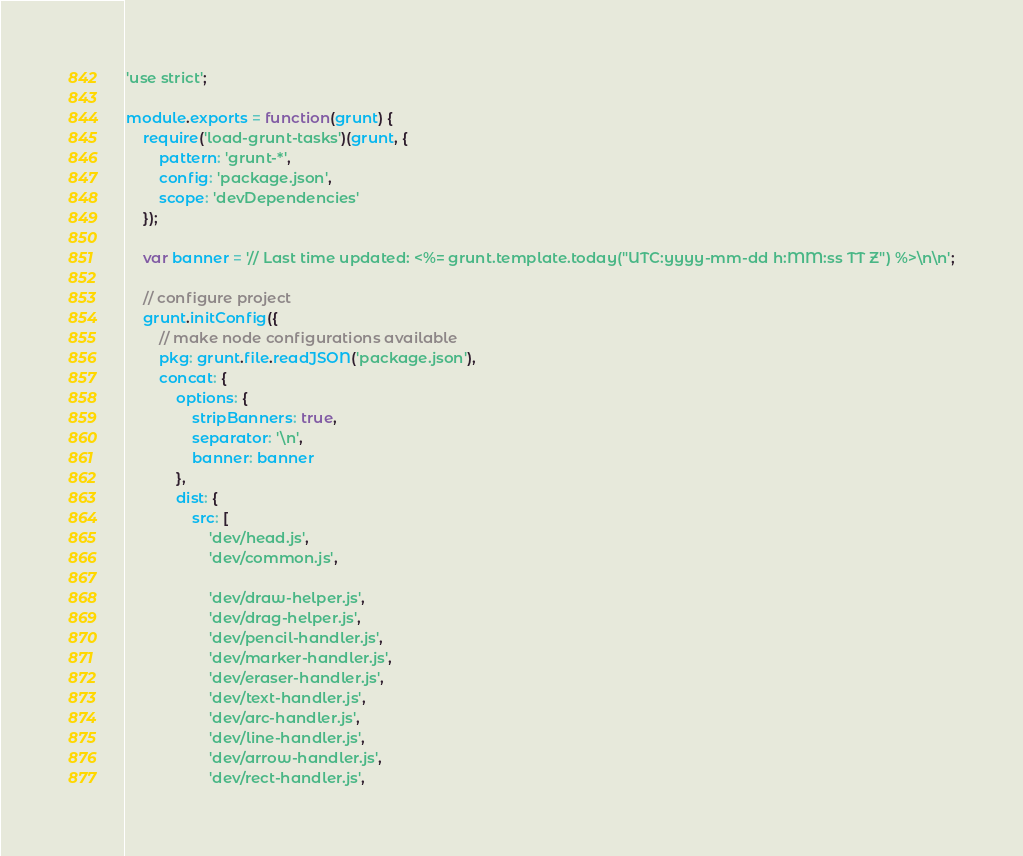<code> <loc_0><loc_0><loc_500><loc_500><_JavaScript_>'use strict';

module.exports = function(grunt) {
    require('load-grunt-tasks')(grunt, {
        pattern: 'grunt-*',
        config: 'package.json',
        scope: 'devDependencies'
    });

    var banner = '// Last time updated: <%= grunt.template.today("UTC:yyyy-mm-dd h:MM:ss TT Z") %>\n\n';

    // configure project
    grunt.initConfig({
        // make node configurations available
        pkg: grunt.file.readJSON('package.json'),
        concat: {
            options: {
                stripBanners: true,
                separator: '\n',
                banner: banner
            },
            dist: {
                src: [
                    'dev/head.js',
                    'dev/common.js',

                    'dev/draw-helper.js',
                    'dev/drag-helper.js',
                    'dev/pencil-handler.js',
                    'dev/marker-handler.js',
                    'dev/eraser-handler.js',
                    'dev/text-handler.js',
                    'dev/arc-handler.js',
                    'dev/line-handler.js',
                    'dev/arrow-handler.js',
                    'dev/rect-handler.js',</code> 